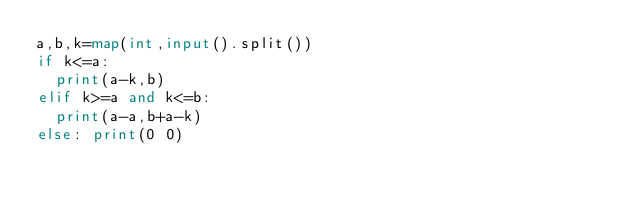Convert code to text. <code><loc_0><loc_0><loc_500><loc_500><_Python_>a,b,k=map(int,input().split())
if k<=a:
	print(a-k,b)
elif k>=a and k<=b:
	print(a-a,b+a-k)
else: print(0 0)
</code> 